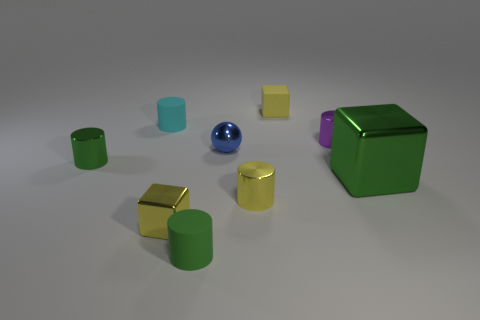Do the tiny rubber block and the tiny metallic block have the same color?
Give a very brief answer. Yes. Is there anything else that has the same size as the green matte cylinder?
Your answer should be very brief. Yes. There is a tiny matte thing that is to the right of the blue metal object; does it have the same shape as the blue object?
Offer a terse response. No. Are there more small matte things behind the yellow cylinder than big blocks?
Make the answer very short. Yes. There is a big thing that is in front of the tiny green object that is behind the small yellow shiny cylinder; what is its color?
Ensure brevity in your answer.  Green. What number of large spheres are there?
Keep it short and to the point. 0. What number of cubes are in front of the green metal cylinder and behind the large green object?
Your response must be concise. 0. Are there any other things that are the same shape as the big object?
Your answer should be very brief. Yes. Is the color of the sphere the same as the cylinder on the right side of the yellow rubber block?
Provide a succinct answer. No. The yellow thing that is behind the blue shiny ball has what shape?
Give a very brief answer. Cube. 